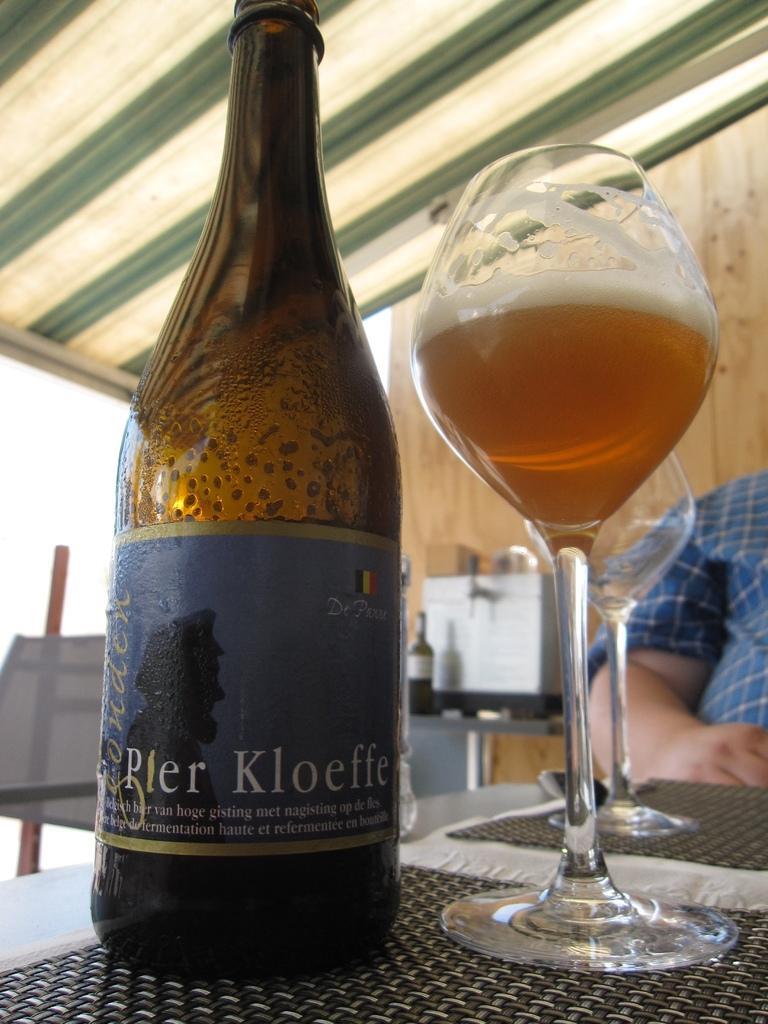Can you describe this image briefly? In this picture there is a bottle on the left side of the image and there are glasses on the right side of the image, which are placed on the table and there is a man in the background area of the image, there are other bottles on the desk in the background area of the image, there is a roof at the top side of the image. 